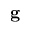<formula> <loc_0><loc_0><loc_500><loc_500>g</formula> 